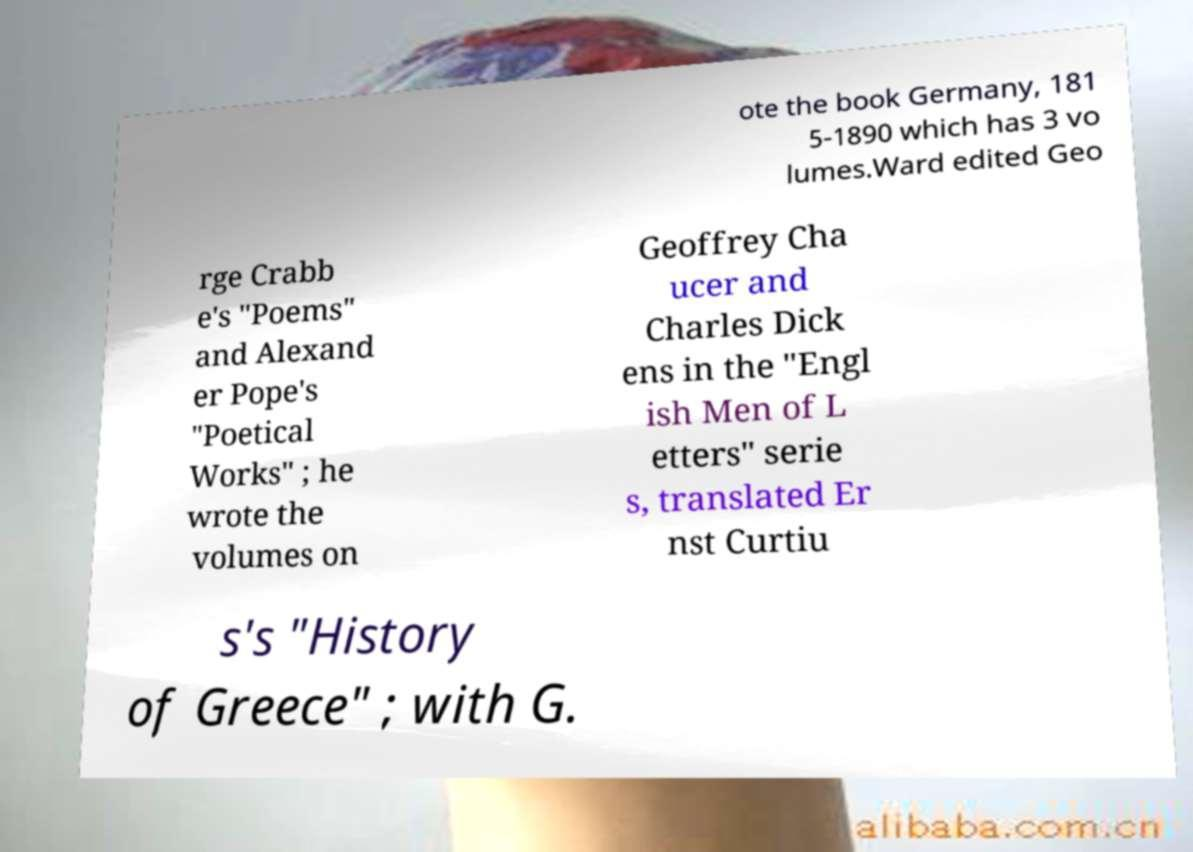Could you assist in decoding the text presented in this image and type it out clearly? ote the book Germany, 181 5-1890 which has 3 vo lumes.Ward edited Geo rge Crabb e's "Poems" and Alexand er Pope's "Poetical Works" ; he wrote the volumes on Geoffrey Cha ucer and Charles Dick ens in the "Engl ish Men of L etters" serie s, translated Er nst Curtiu s's "History of Greece" ; with G. 